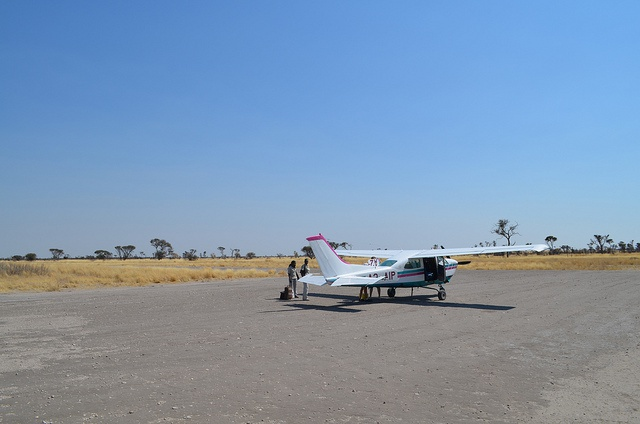Describe the objects in this image and their specific colors. I can see airplane in gray, lightgray, black, lightblue, and darkgray tones, people in gray, black, darkgray, and tan tones, people in gray, black, and darkgray tones, people in gray, black, and darkgreen tones, and people in gray and black tones in this image. 